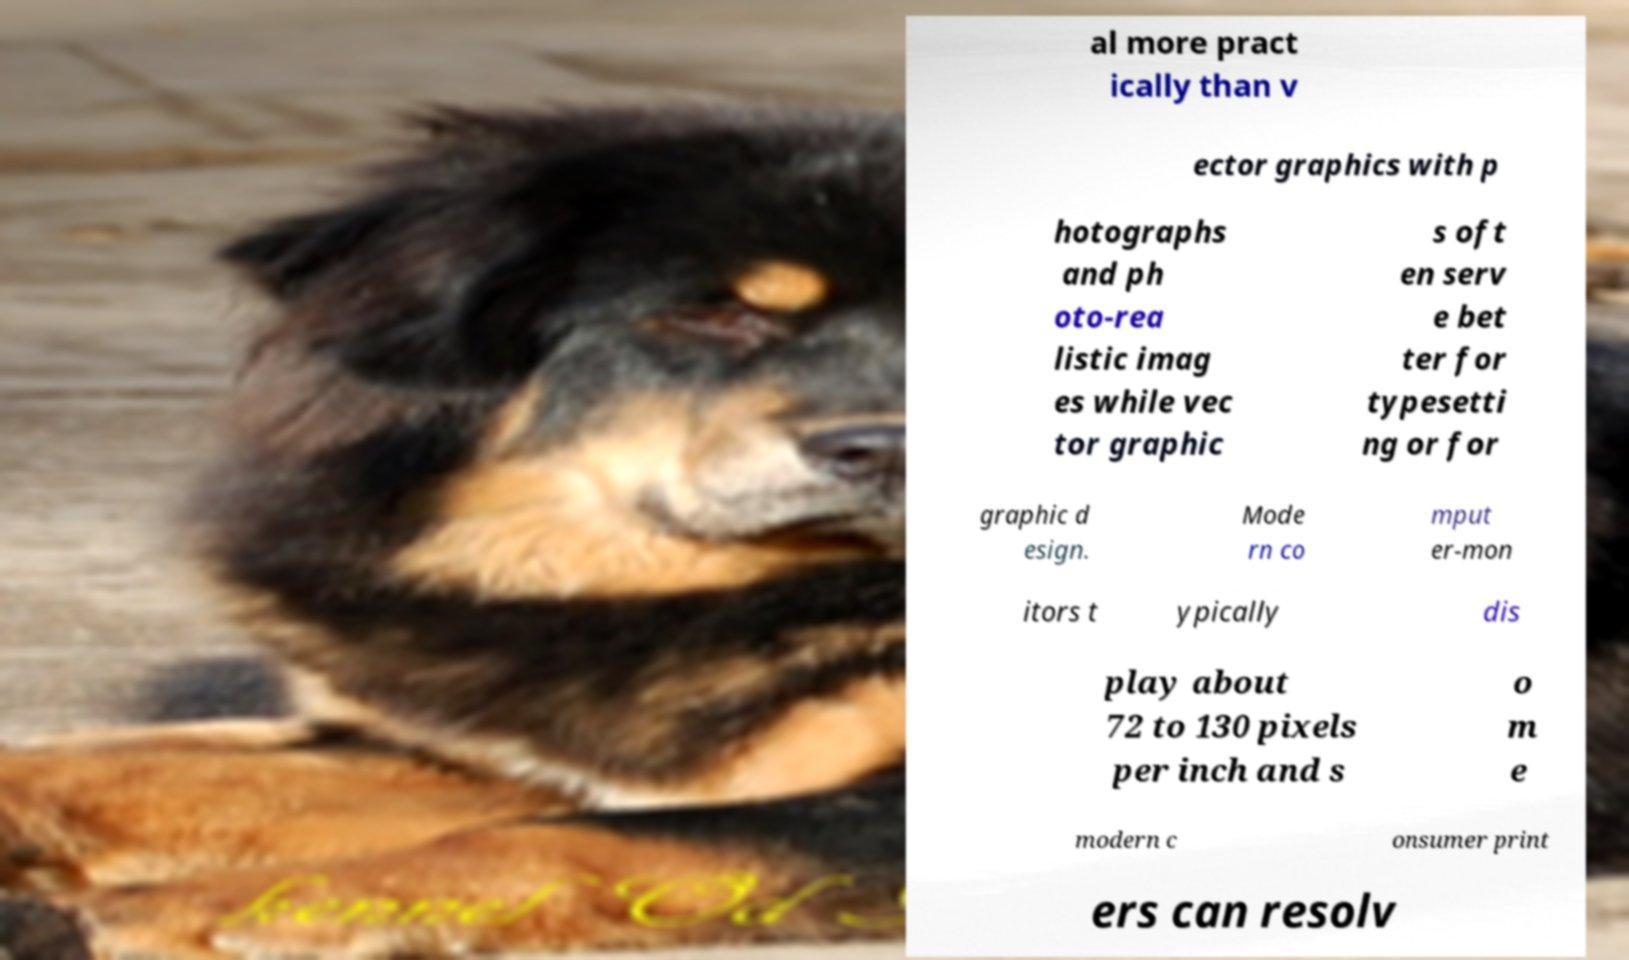Can you accurately transcribe the text from the provided image for me? al more pract ically than v ector graphics with p hotographs and ph oto-rea listic imag es while vec tor graphic s oft en serv e bet ter for typesetti ng or for graphic d esign. Mode rn co mput er-mon itors t ypically dis play about 72 to 130 pixels per inch and s o m e modern c onsumer print ers can resolv 